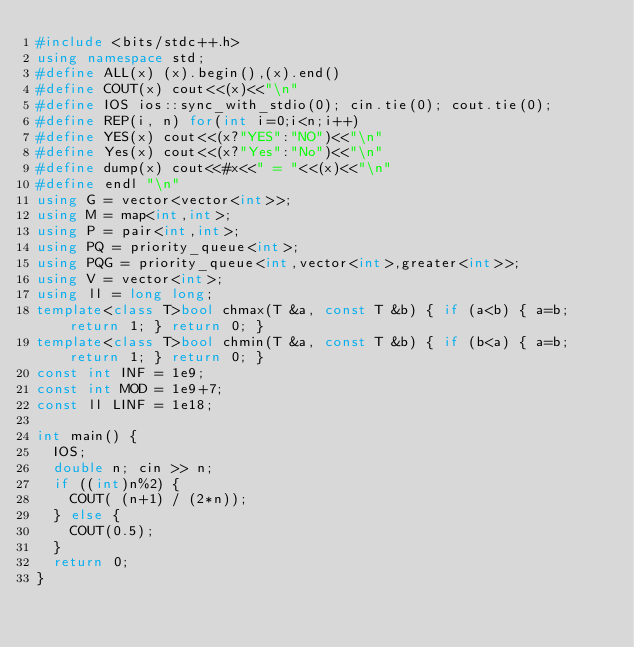<code> <loc_0><loc_0><loc_500><loc_500><_C++_>#include <bits/stdc++.h>
using namespace std;
#define ALL(x) (x).begin(),(x).end()
#define COUT(x) cout<<(x)<<"\n"
#define IOS ios::sync_with_stdio(0); cin.tie(0); cout.tie(0);
#define REP(i, n) for(int i=0;i<n;i++)
#define YES(x) cout<<(x?"YES":"NO")<<"\n"
#define Yes(x) cout<<(x?"Yes":"No")<<"\n"
#define dump(x) cout<<#x<<" = "<<(x)<<"\n"
#define endl "\n"
using G = vector<vector<int>>;
using M = map<int,int>;
using P = pair<int,int>;
using PQ = priority_queue<int>;
using PQG = priority_queue<int,vector<int>,greater<int>>;
using V = vector<int>;
using ll = long long;
template<class T>bool chmax(T &a, const T &b) { if (a<b) { a=b; return 1; } return 0; }
template<class T>bool chmin(T &a, const T &b) { if (b<a) { a=b; return 1; } return 0; }
const int INF = 1e9;
const int MOD = 1e9+7;
const ll LINF = 1e18;

int main() {
  IOS;
  double n; cin >> n;
  if ((int)n%2) {
    COUT( (n+1) / (2*n));
  } else {
    COUT(0.5);
  }
  return 0;
}</code> 